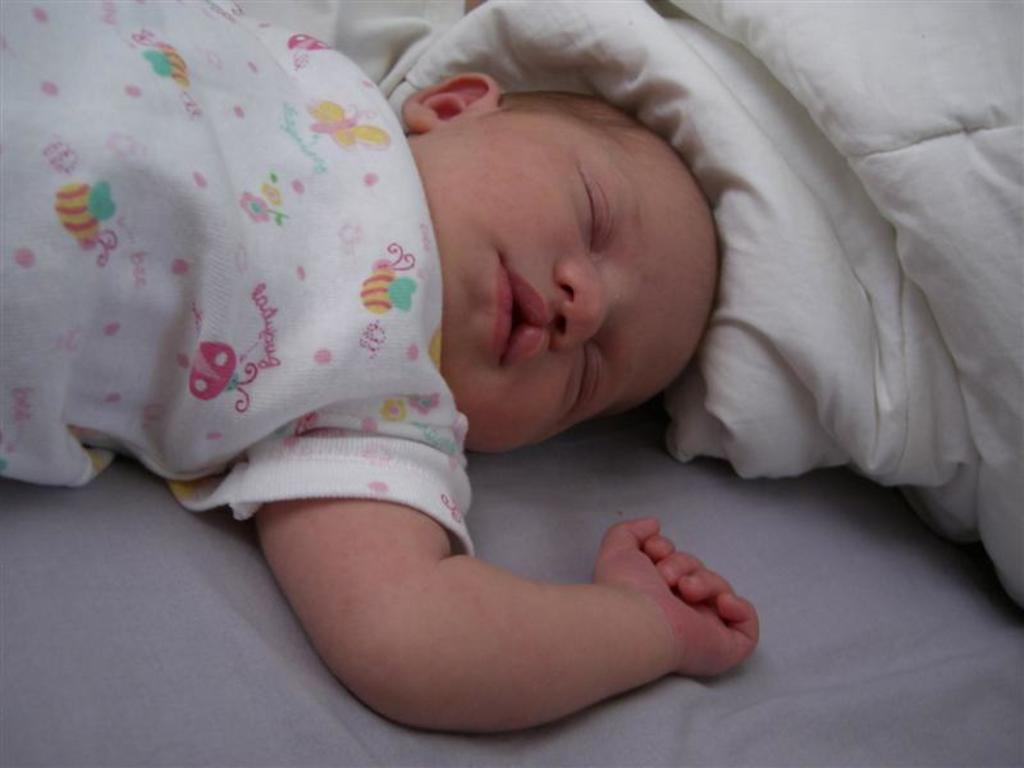What is the main subject of the image? There is a baby in the image. What is the baby wearing? The baby is wearing a white t-shirt. Where is the baby located in the image? The baby is lying on a bed. What is covering the top of the bed? There is a white blanket at the top of the bed. What design is on the baby's t-shirt? The t-shirt has pictures of honey bees and flowers on it. What type of cough medicine is the baby holding in the image? There is no cough medicine present in the image; the baby is wearing a white t-shirt with pictures of honey bees and flowers on it. What is the baby writing on the railway in the image? There is no railway or writing activity present in the image; the baby is lying on a bed with a white blanket. 